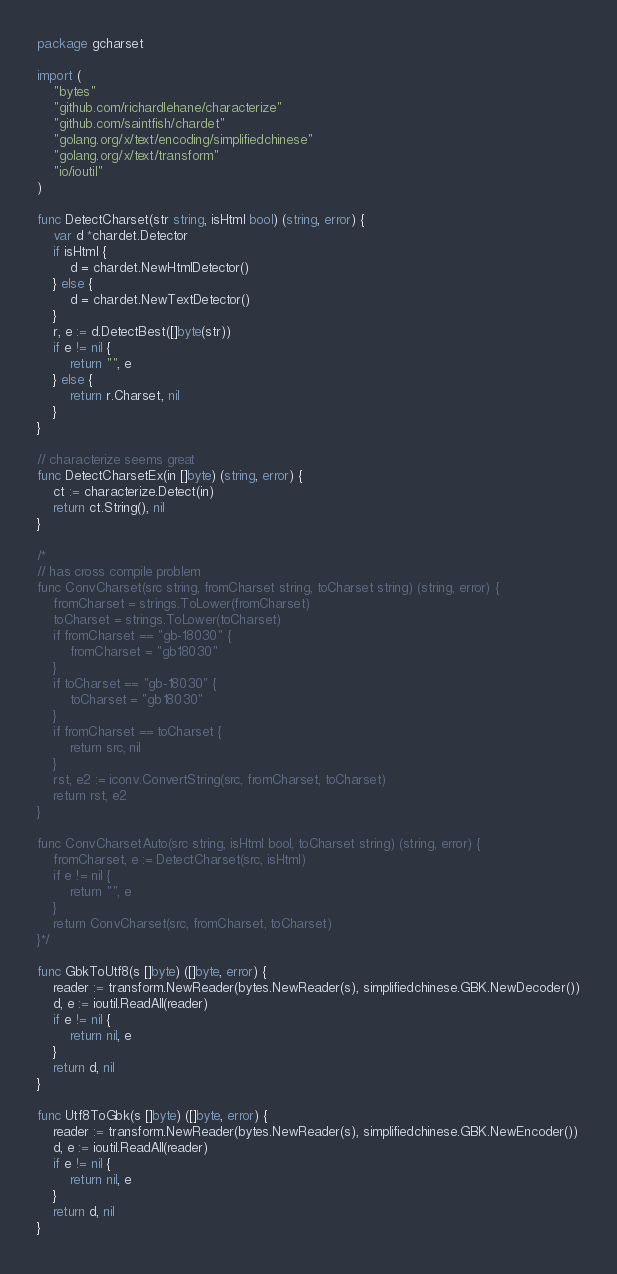Convert code to text. <code><loc_0><loc_0><loc_500><loc_500><_Go_>package gcharset

import (
	"bytes"
	"github.com/richardlehane/characterize"
	"github.com/saintfish/chardet"
	"golang.org/x/text/encoding/simplifiedchinese"
	"golang.org/x/text/transform"
	"io/ioutil"
)

func DetectCharset(str string, isHtml bool) (string, error) {
	var d *chardet.Detector
	if isHtml {
		d = chardet.NewHtmlDetector()
	} else {
		d = chardet.NewTextDetector()
	}
	r, e := d.DetectBest([]byte(str))
	if e != nil {
		return "", e
	} else {
		return r.Charset, nil
	}
}

// characterize seems great
func DetectCharsetEx(in []byte) (string, error) {
	ct := characterize.Detect(in)
	return ct.String(), nil
}

/*
// has cross compile problem
func ConvCharset(src string, fromCharset string, toCharset string) (string, error) {
	fromCharset = strings.ToLower(fromCharset)
	toCharset = strings.ToLower(toCharset)
	if fromCharset == "gb-18030" {
		fromCharset = "gb18030"
	}
	if toCharset == "gb-18030" {
		toCharset = "gb18030"
	}
	if fromCharset == toCharset {
		return src, nil
	}
	rst, e2 := iconv.ConvertString(src, fromCharset, toCharset)
	return rst, e2
}

func ConvCharsetAuto(src string, isHtml bool, toCharset string) (string, error) {
	fromCharset, e := DetectCharset(src, isHtml)
	if e != nil {
		return "", e
	}
	return ConvCharset(src, fromCharset, toCharset)
}*/

func GbkToUtf8(s []byte) ([]byte, error) {
	reader := transform.NewReader(bytes.NewReader(s), simplifiedchinese.GBK.NewDecoder())
	d, e := ioutil.ReadAll(reader)
	if e != nil {
		return nil, e
	}
	return d, nil
}

func Utf8ToGbk(s []byte) ([]byte, error) {
	reader := transform.NewReader(bytes.NewReader(s), simplifiedchinese.GBK.NewEncoder())
	d, e := ioutil.ReadAll(reader)
	if e != nil {
		return nil, e
	}
	return d, nil
}
</code> 